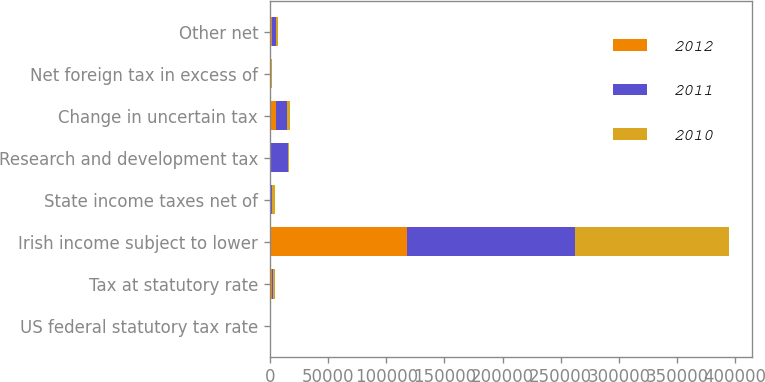Convert chart to OTSL. <chart><loc_0><loc_0><loc_500><loc_500><stacked_bar_chart><ecel><fcel>US federal statutory tax rate<fcel>Tax at statutory rate<fcel>Irish income subject to lower<fcel>State income taxes net of<fcel>Research and development tax<fcel>Change in uncertain tax<fcel>Net foreign tax in excess of<fcel>Other net<nl><fcel>2012<fcel>35<fcel>1376<fcel>117693<fcel>610<fcel>964<fcel>5184<fcel>14<fcel>1376<nl><fcel>2011<fcel>35<fcel>1376<fcel>144845<fcel>1162<fcel>14681<fcel>9897<fcel>338<fcel>3670<nl><fcel>2010<fcel>35<fcel>1376<fcel>131823<fcel>2622<fcel>1045<fcel>2082<fcel>1315<fcel>1706<nl></chart> 